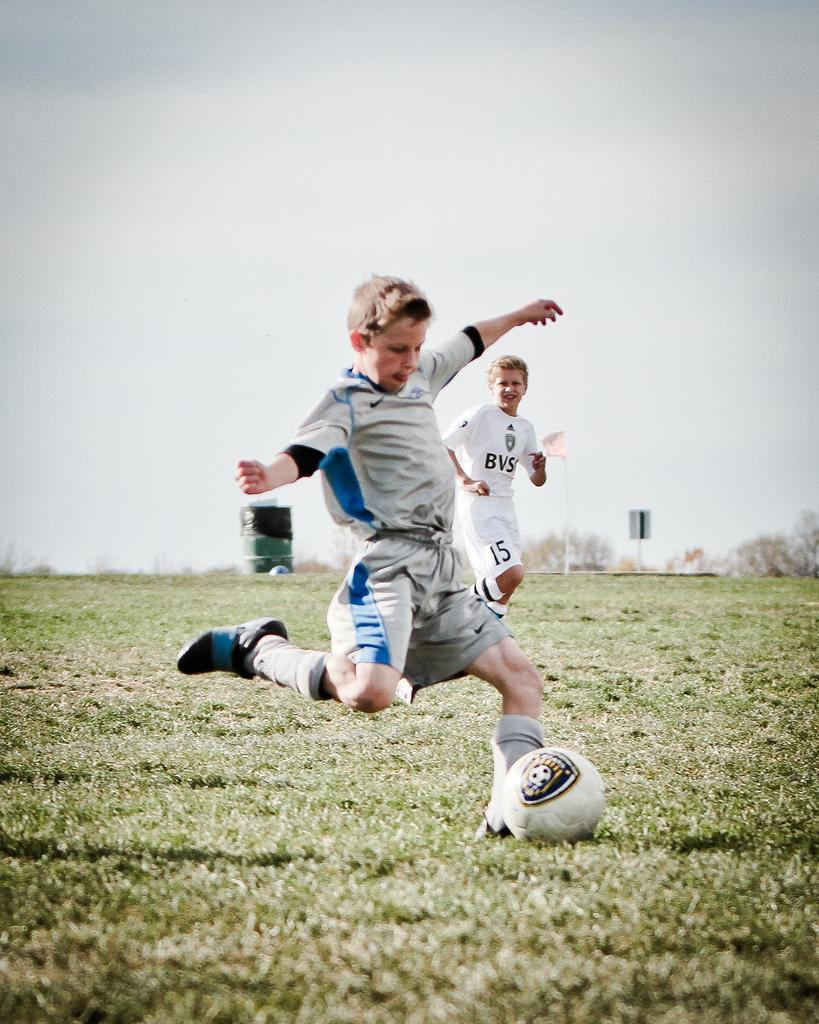Can you describe this image briefly? In this image in the center there are two boys who are playing football. At the bottom there is grass and in the background there are some trees and sky. 